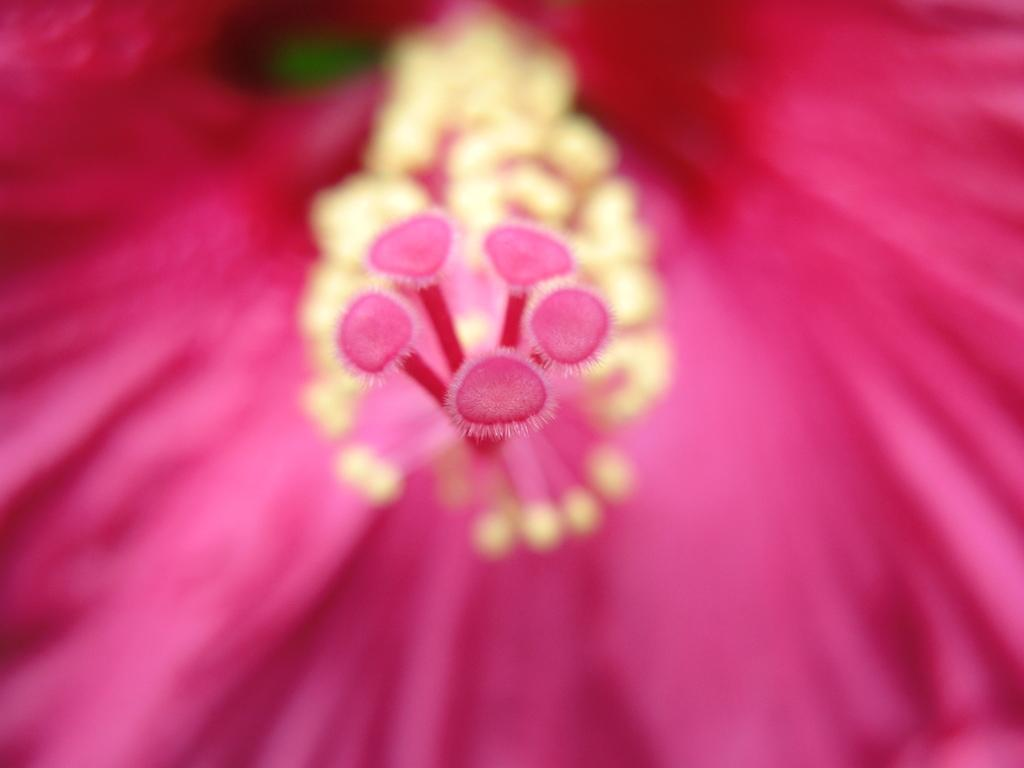What type of flower is in the picture? There is a pink color flower in the picture. Can you describe any specific features of the flower? The flower has anthers. What news is being reported by the flower in the picture? There is no news being reported by the flower in the picture, as flowers do not have the ability to report news. 